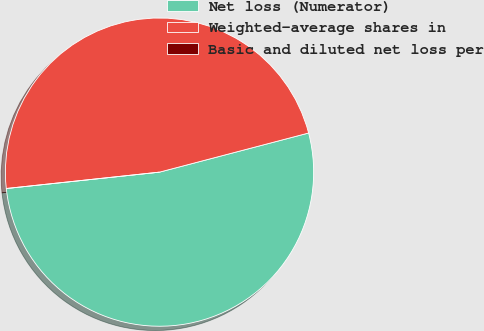<chart> <loc_0><loc_0><loc_500><loc_500><pie_chart><fcel>Net loss (Numerator)<fcel>Weighted-average shares in<fcel>Basic and diluted net loss per<nl><fcel>52.39%<fcel>47.61%<fcel>0.0%<nl></chart> 